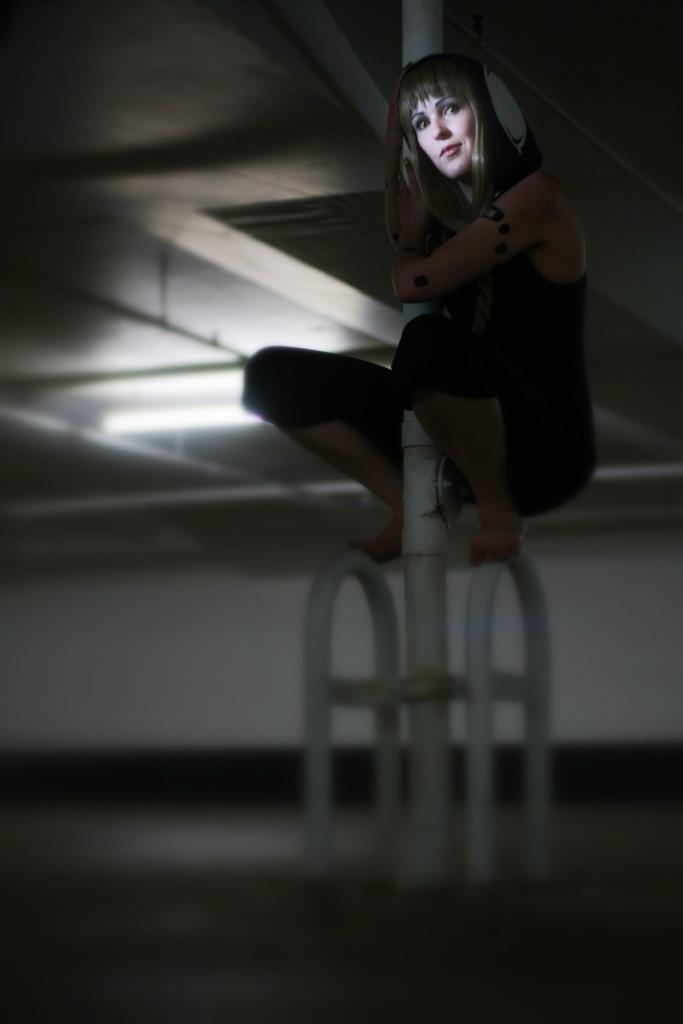Who is the main subject in the image? There is a woman in the image. What is the woman doing in the image? The woman is sitting on a rod. What is the woman wearing in the image? The woman is wearing a black dress. What color are the rods in the image? There are white rods in the image. What is the setting of the image? There is a floor at the bottom of the image and a roof at the top of the image. What type of parenting advice can be seen in the image? There is no parenting advice present in the image; it features a woman sitting on a rod. What type of adjustment is the woman making with her partner in the image? There is no partner present in the image, and the woman is not making any adjustments; she is simply sitting on a rod. 